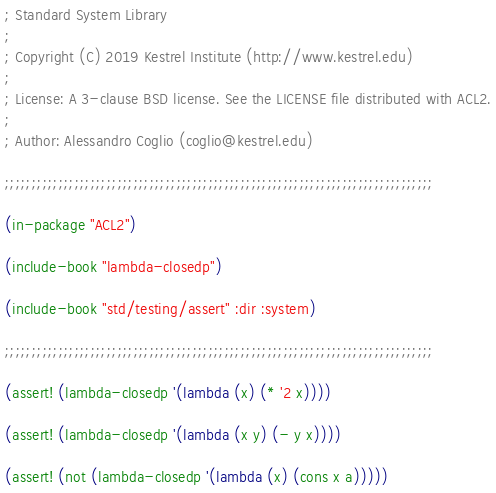Convert code to text. <code><loc_0><loc_0><loc_500><loc_500><_Lisp_>; Standard System Library
;
; Copyright (C) 2019 Kestrel Institute (http://www.kestrel.edu)
;
; License: A 3-clause BSD license. See the LICENSE file distributed with ACL2.
;
; Author: Alessandro Coglio (coglio@kestrel.edu)

;;;;;;;;;;;;;;;;;;;;;;;;;;;;;;;;;;;;;;;;;;;;;;;;;;;;;;;;;;;;;;;;;;;;;;;;;;;;;;;;

(in-package "ACL2")

(include-book "lambda-closedp")

(include-book "std/testing/assert" :dir :system)

;;;;;;;;;;;;;;;;;;;;;;;;;;;;;;;;;;;;;;;;;;;;;;;;;;;;;;;;;;;;;;;;;;;;;;;;;;;;;;;;

(assert! (lambda-closedp '(lambda (x) (* '2 x))))

(assert! (lambda-closedp '(lambda (x y) (- y x))))

(assert! (not (lambda-closedp '(lambda (x) (cons x a)))))
</code> 